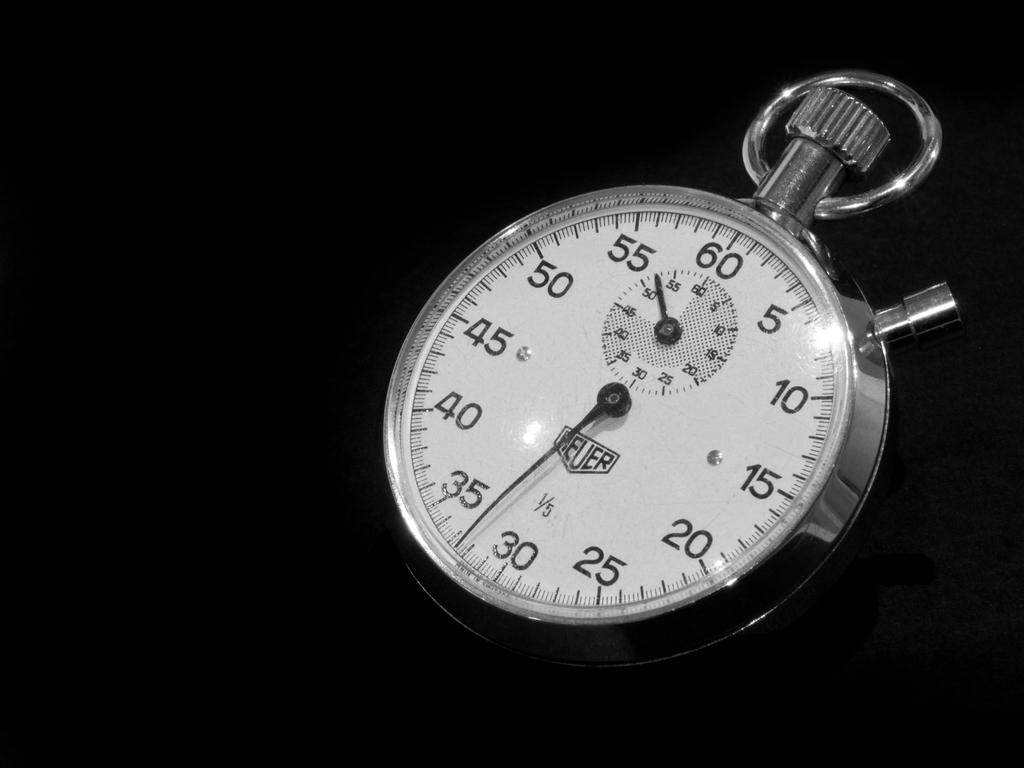What is the main object in the image? There is a dial in the image. What color is the background of the image? The background of the image is black. What direction does the pocket in the image face? There is no pocket present in the image. What effect does the dial have on the surrounding environment in the image? The provided facts do not mention any effect the dial has on the surrounding environment, so we cannot answer this question definitively. 